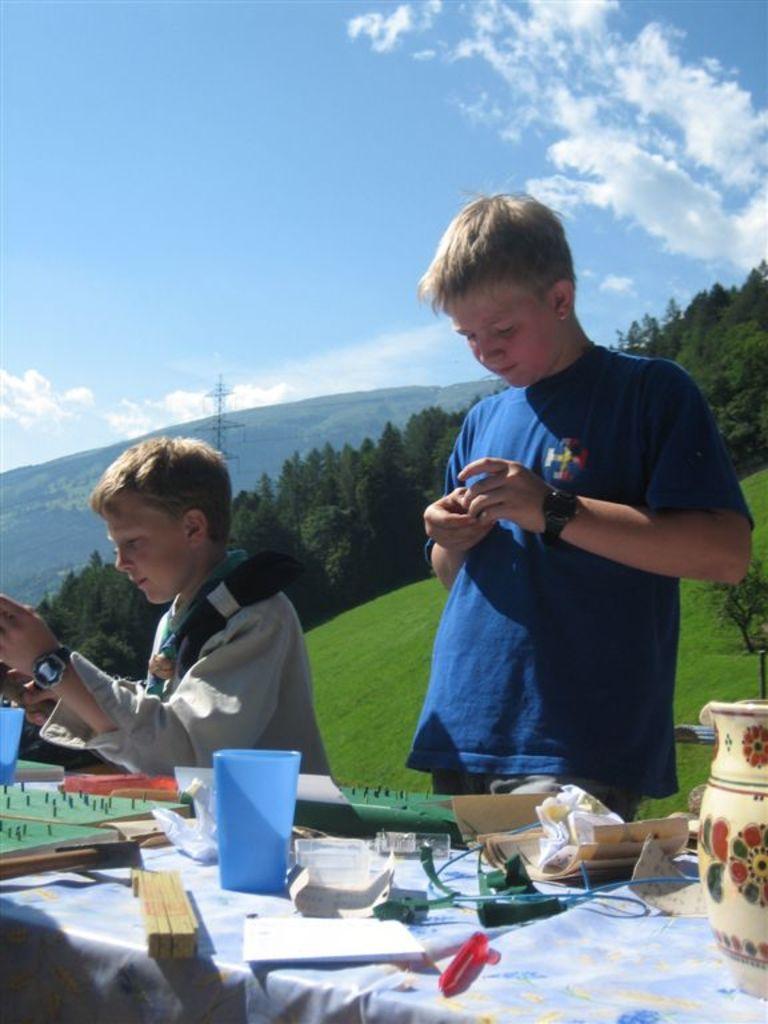In one or two sentences, can you explain what this image depicts? In the middle of the image there is a sky and clouds. Bottom left side of the image there is a table, On the table there is a glass and there are some products. Right side of the image there is a man holding something in his hands. Bottom left side of the image a boy is standing, Behind them there are some trees and hill. 